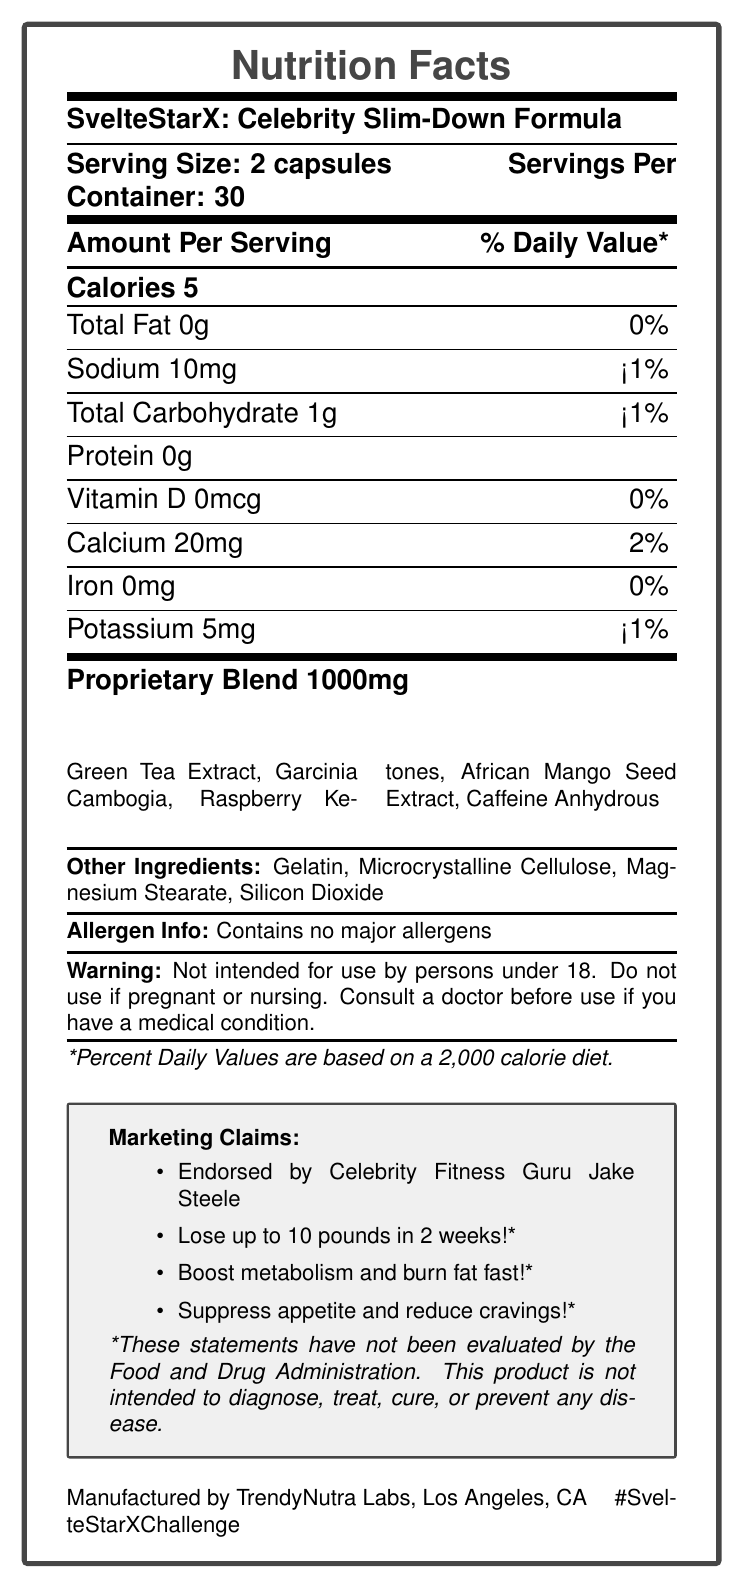what is the serving size for SvelteStarX? The serving size is listed at the top part of the document as "Serving Size: 2 capsules".
Answer: 2 capsules how many calories are in one serving of SvelteStarX? The document states "Calories 5" under the section "Amount Per Serving".
Answer: 5 calories what is the proprietary blend amount per serving in SvelteStarX? The proprietary blend amount is given in the document under "Proprietary Blend 1000mg".
Answer: 1000mg which celebrity endorses SvelteStarX? The document mentions "Endorsed by Celebrity Fitness Guru Jake Steele" in the Marketing Claims section.
Answer: Jake Steele how many servings are there per container of SvelteStarX? The number of servings per container is provided as "Servings Per Container: 30".
Answer: 30 what percentage of daily value does sodium make up in one serving? Sodium content is 10mg, which is listed as "<1%" of the daily value.
Answer: <1% can the product SvelteStarX be used by pregnant women? The warning section in the document clearly states, "Do not use if pregnant or nursing."
Answer: No which of the following ingredients is NOT part of the proprietary blend?
A. Microcrystalline Cellulose
B. Green Tea Extract
C. Raspberry Ketones
D. Garcinia Cambogia Microcrystalline Cellulose is listed under "Other Ingredients" while Green Tea Extract, Raspberry Ketones, and Garcinia Cambogia are part of the proprietary blend.
Answer: A what is the social media hashtag associated with SvelteStarX? The document includes the social media hashtag "#SvelteStarXChallenge" at the bottom part of the page.
Answer: #SvelteStarXChallenge what is the claim about weight loss made in the document? The marketing claims section lists "Lose up to 10 pounds in 2 weeks!*" as one of the product's promises.
Answer: Lose up to 10 pounds in 2 weeks!* is SvelteStarX allergen-free? The document states "Contains no major allergens" under the allergen information.
Answer: Yes the proprietary blend ingredients include which of the following?
(i) Green Tea Extract
(ii) Microcrystalline Cellulose
(iii) Garcinia Cambogia
(iv) African Mango Seed Extract
A. i, ii, iii
B. i, iii, iv
C. ii, iii, iv
D. i, ii, iv The proprietary blend includes "Green Tea Extract", "Garcinia Cambogia", and "African Mango Seed Extract".
Answer: B what is the main idea of the document? The document includes various sections such as nutrition facts, proprietary blend details, ingredients list, allergen information, warnings, and marketing claims, giving a comprehensive view of the product.
Answer: The document provides the nutrition facts and detailed information about SvelteStarX: Celebrity Slim-Down Formula, including its ingredients, serving size, and marketing claims. It highlights the product's endorsement by a celebrity, Jake Steele, and contains a disclaimer noting that the weight loss claims have not been evaluated by the FDA. how much iron does SvelteStarX contain per serving? The document states that the iron content per serving is 0 mg under the "Amount Per Serving" section.
Answer: 0 mg is there any specific warning for underage users of SvelteStarX? The warning section of the document explicitly mentions "Not intended for use by persons under 18."
Answer: Yes, it says "Not intended for use by persons under 18." has the effectiveness of the weight loss claims been evaluated by the FDA? The disclaimer in the document states, "*These statements have not been evaluated by the Food and Drug Administration."
Answer: No what clinical studies support the weight loss claims? The document does not provide any information about clinical studies supporting the weight loss claims.
Answer: Cannot be determined 